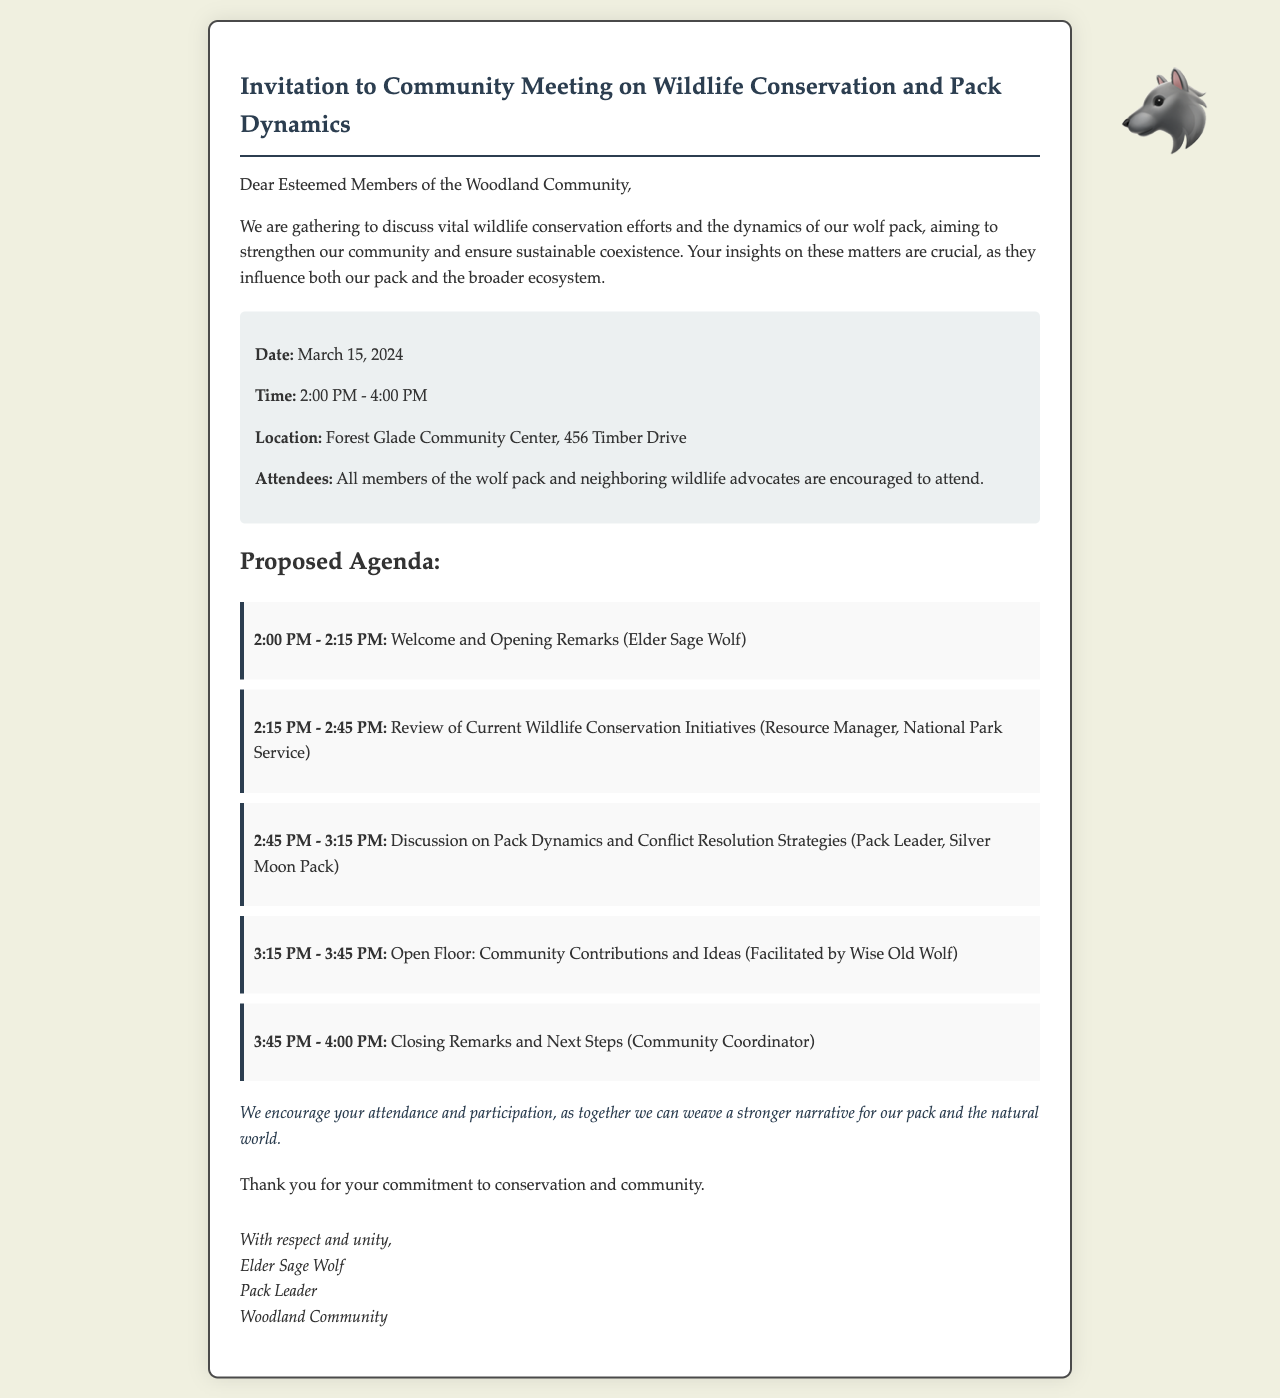What is the date of the meeting? The date of the meeting is explicitly mentioned in the document.
Answer: March 15, 2024 What is the time of the meeting? The time specified in the document outlines the duration of the meeting.
Answer: 2:00 PM - 4:00 PM Where is the meeting location? The document states the venue for the meeting.
Answer: Forest Glade Community Center, 456 Timber Drive Who is facilitating the open floor discussion? The facilitator for the open floor session is identified in the agenda section of the document.
Answer: Wise Old Wolf What is one of the topics of discussion? The agenda lists specific topics to be covered during the meeting.
Answer: Pack Dynamics and Conflict Resolution Strategies How long is the opening remarks session? The duration of the opening remarks can be calculated based on the agenda item timings.
Answer: 15 minutes What role does Elder Sage Wolf hold? The document explicitly states Elder Sage Wolf's position in the community.
Answer: Pack Leader What is the purpose of the meeting? The letter outlines the overall intention behind organizing the meeting.
Answer: Wildlife conservation efforts and the dynamics of our wolf pack What is encouraged after the meeting? The call-to-action mentions a specific outcome desired from attendance and participation.
Answer: Attendance and participation 